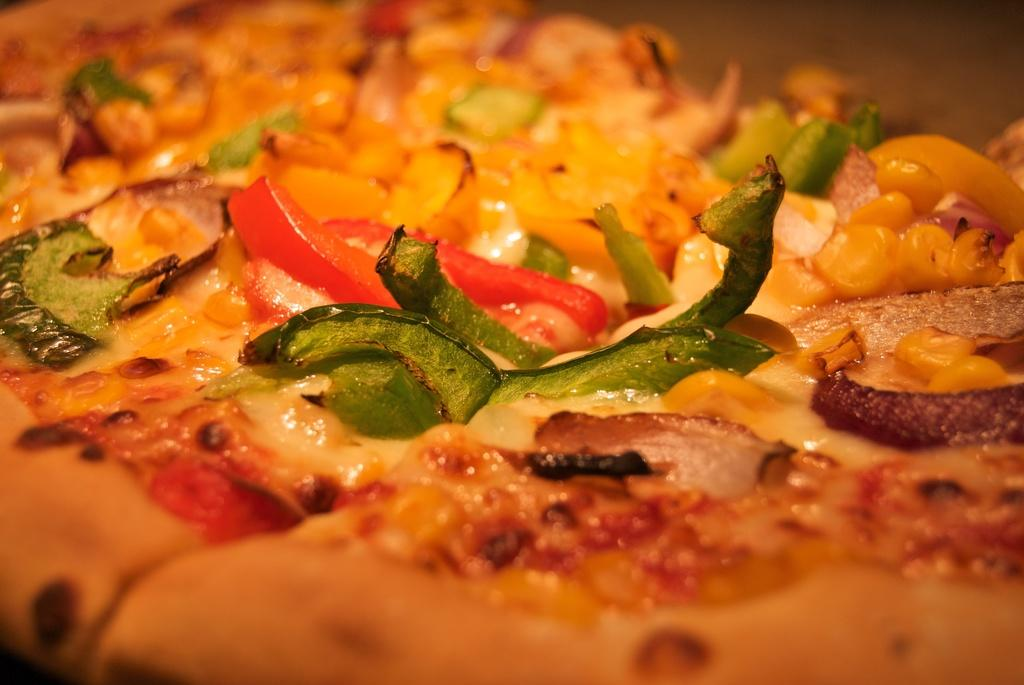What is present in the image? There is a dish in the image in the image. What type of cabbage can be seen growing in the dish? There is no cabbage present in the image; only a dish is visible. What color is the rose that is placed on the dish? There is no rose present in the image; only a dish is visible. 